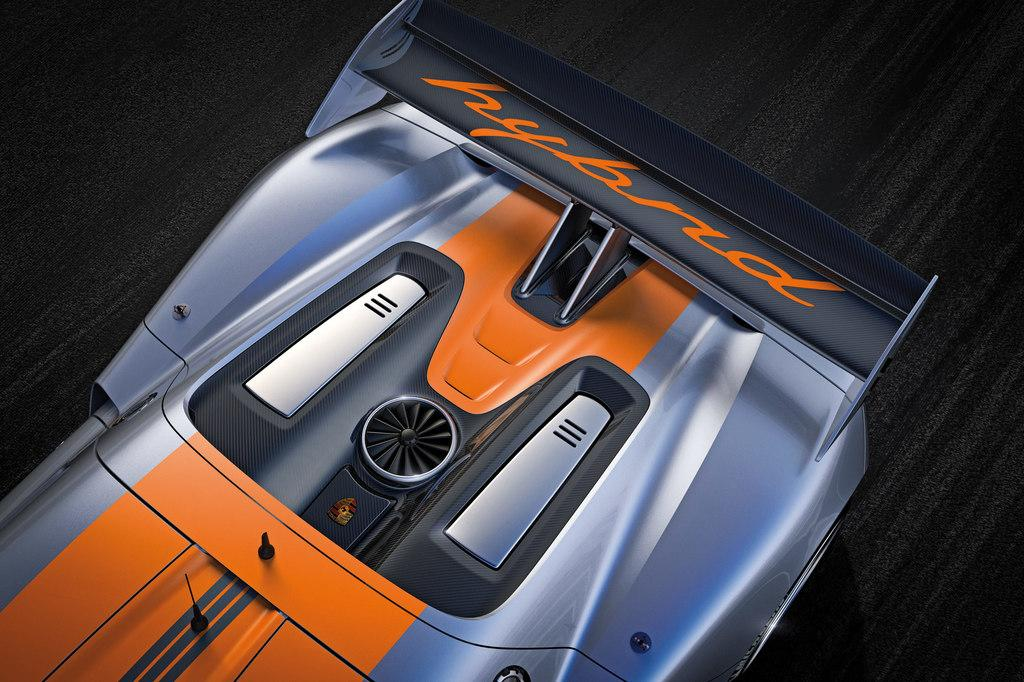What is the main subject of the image? The main subject of the image is a race car. Can you describe the colors of the race car? The race car is grey, black, and orange in color. What color is the background of the image? The background of the image is black. What type of print can be seen on the engine of the race car in the image? There is no print visible on the engine of the race car in the image, as the engine is not shown. How does the race car blow out smoke in the image? The race car does not blow out smoke in the image; there is no indication of any smoke or exhaust. 